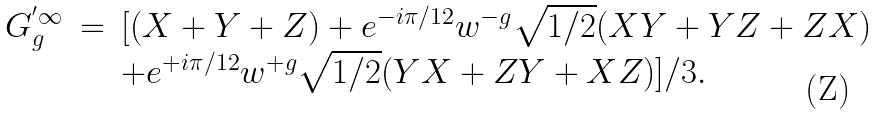Convert formula to latex. <formula><loc_0><loc_0><loc_500><loc_500>\begin{array} { r c l } G _ { g } ^ { ^ { \prime } \infty } & = & [ ( X + Y + Z ) + e ^ { - i \pi / 1 2 } w ^ { - g } \sqrt { 1 / 2 } ( X Y + Y Z + Z X ) \\ & & + e ^ { + i \pi / 1 2 } w ^ { + g } \sqrt { 1 / 2 } ( Y X + Z Y + X Z ) ] / 3 . \end{array}</formula> 